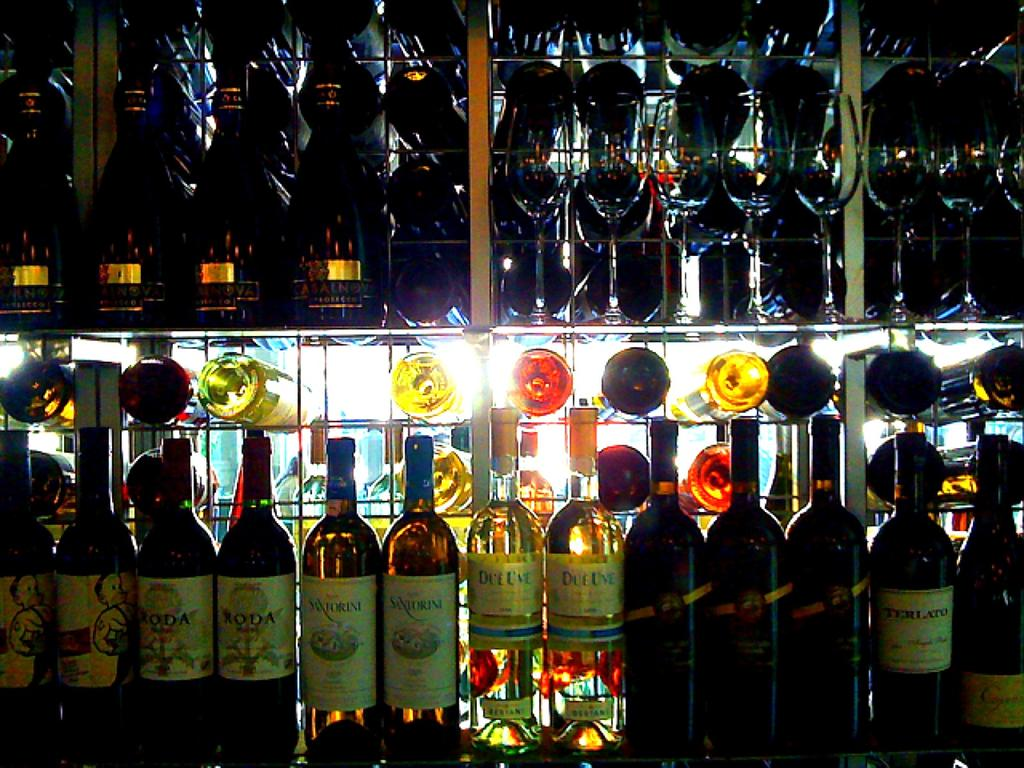What type of beverage containers are present in the image? There are wine bottles in the image. Can you see any rats interacting with the wine bottles in the image? There are no rats present in the image, and therefore no such interaction can be observed. 